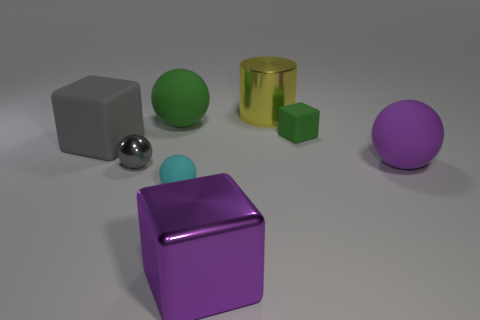Subtract 1 spheres. How many spheres are left? 3 Add 1 small balls. How many objects exist? 9 Subtract all cylinders. How many objects are left? 7 Subtract 0 blue cylinders. How many objects are left? 8 Subtract all large gray objects. Subtract all large gray objects. How many objects are left? 6 Add 5 purple blocks. How many purple blocks are left? 6 Add 3 large gray shiny cylinders. How many large gray shiny cylinders exist? 3 